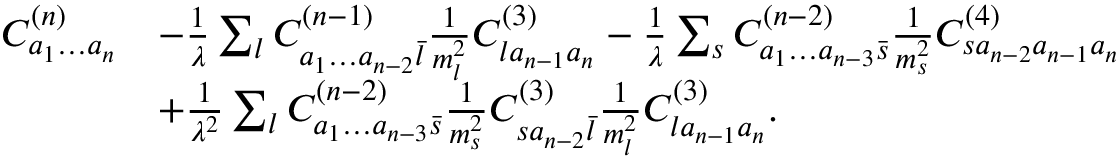<formula> <loc_0><loc_0><loc_500><loc_500>\begin{array} { r l } { C _ { a _ { 1 } \dots a _ { n } } ^ { ( n ) } } & { - \frac { 1 } { \lambda } \sum _ { l } C _ { a _ { 1 } \dots a _ { n - 2 } \bar { l } } ^ { ( n - 1 ) } \frac { 1 } { m _ { l } ^ { 2 } } C _ { l a _ { n - 1 } a _ { n } } ^ { ( 3 ) } - \frac { 1 } { \lambda } \sum _ { s } C _ { a _ { 1 } \dots a _ { n - 3 } \bar { s } } ^ { ( n - 2 ) } \frac { 1 } { m _ { s } ^ { 2 } } C _ { s a _ { n - 2 } a _ { n - 1 } a _ { n } } ^ { ( 4 ) } } \\ & { + \frac { 1 } { \lambda ^ { 2 } } \sum _ { l } C _ { a _ { 1 } \dots a _ { n - 3 } \bar { s } } ^ { ( n - 2 ) } \frac { 1 } { m _ { s } ^ { 2 } } C _ { s a _ { n - 2 } \bar { l } } ^ { ( 3 ) } \frac { 1 } { m _ { l } ^ { 2 } } C _ { l a _ { n - 1 } a _ { n } } ^ { ( 3 ) } . } \end{array}</formula> 